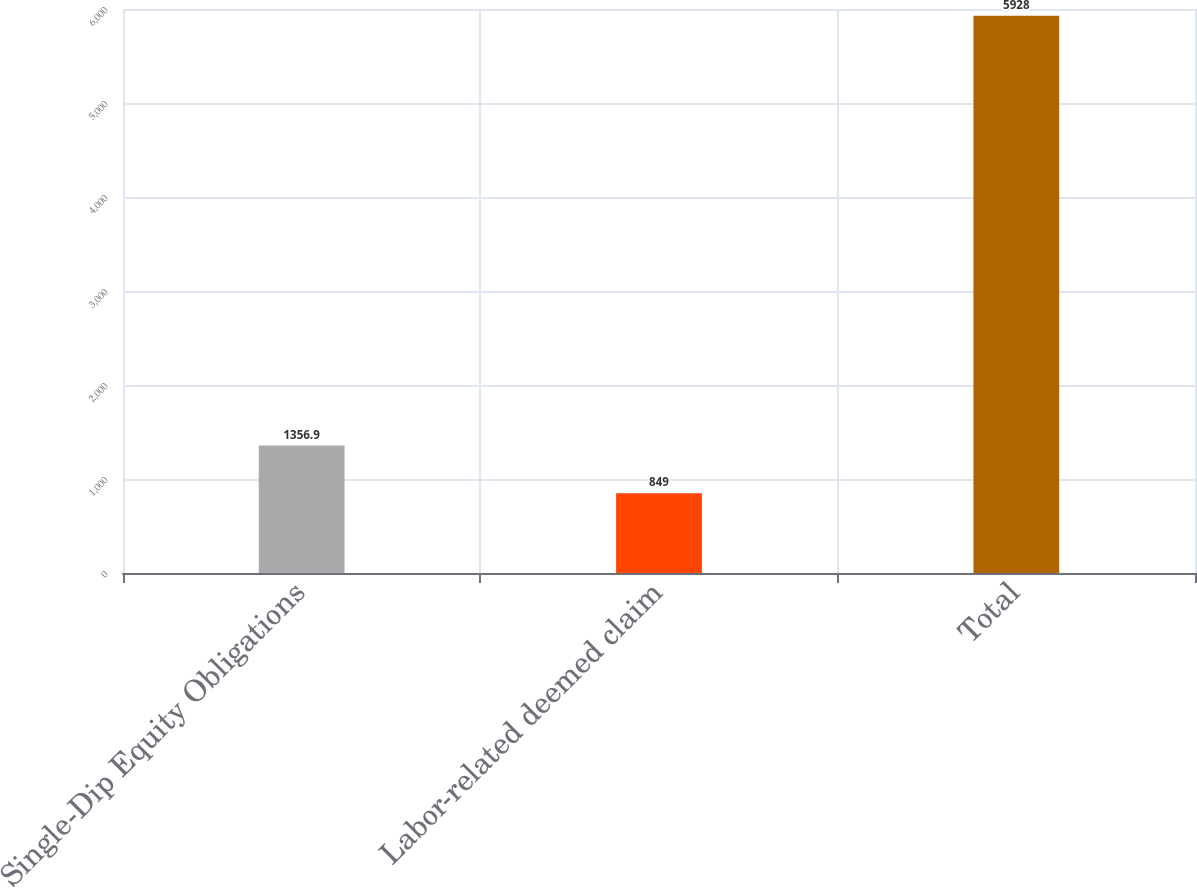Convert chart. <chart><loc_0><loc_0><loc_500><loc_500><bar_chart><fcel>Single-Dip Equity Obligations<fcel>Labor-related deemed claim<fcel>Total<nl><fcel>1356.9<fcel>849<fcel>5928<nl></chart> 